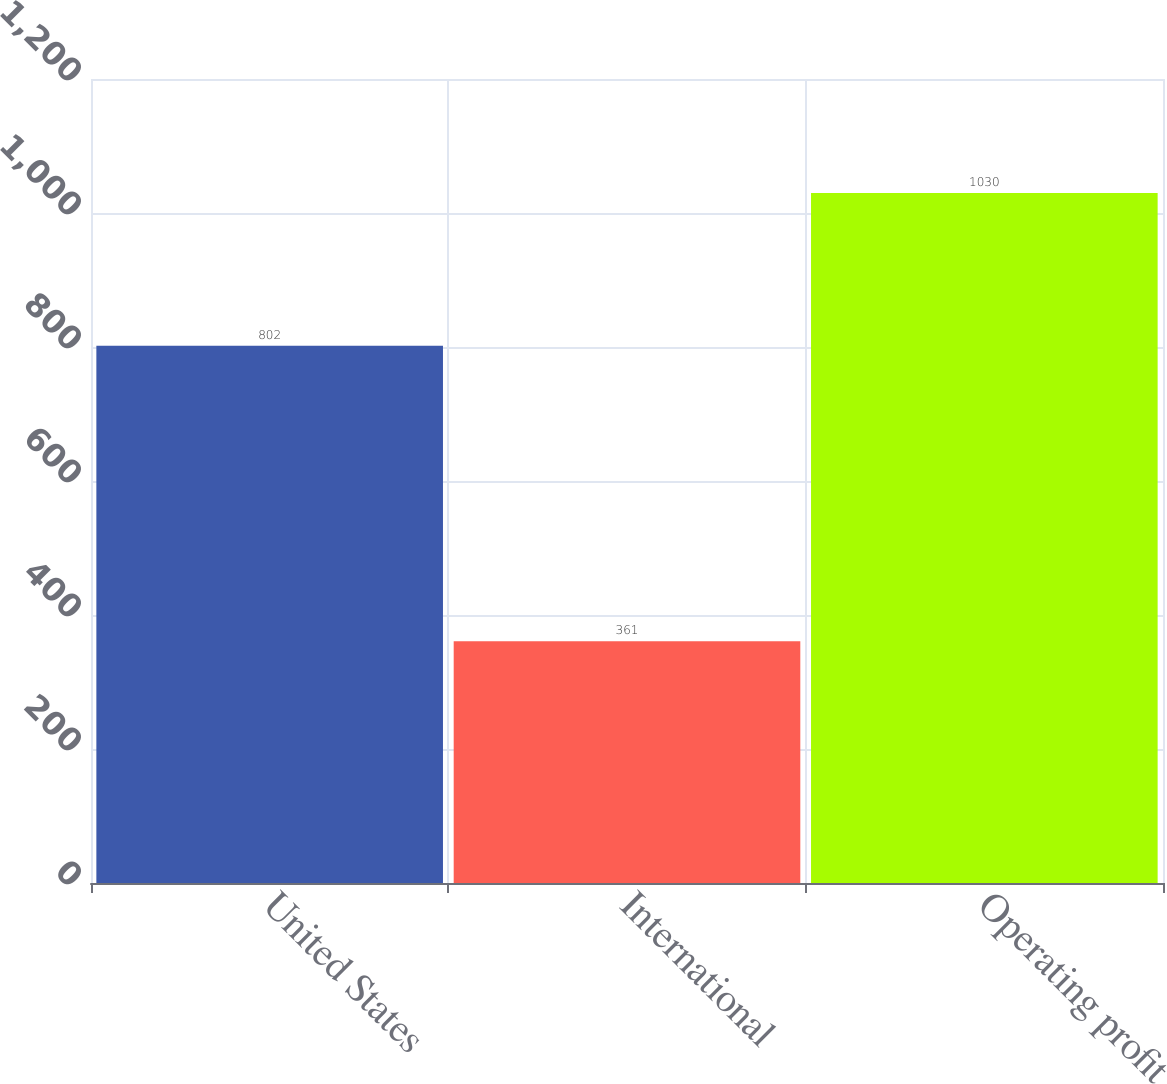Convert chart to OTSL. <chart><loc_0><loc_0><loc_500><loc_500><bar_chart><fcel>United States<fcel>International<fcel>Operating profit<nl><fcel>802<fcel>361<fcel>1030<nl></chart> 